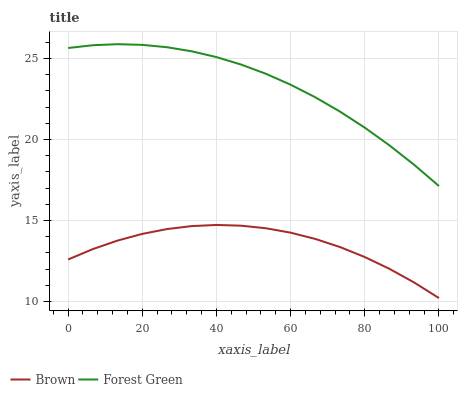Does Brown have the minimum area under the curve?
Answer yes or no. Yes. Does Forest Green have the maximum area under the curve?
Answer yes or no. Yes. Does Forest Green have the minimum area under the curve?
Answer yes or no. No. Is Forest Green the smoothest?
Answer yes or no. Yes. Is Brown the roughest?
Answer yes or no. Yes. Is Forest Green the roughest?
Answer yes or no. No. Does Forest Green have the lowest value?
Answer yes or no. No. Does Forest Green have the highest value?
Answer yes or no. Yes. Is Brown less than Forest Green?
Answer yes or no. Yes. Is Forest Green greater than Brown?
Answer yes or no. Yes. Does Brown intersect Forest Green?
Answer yes or no. No. 